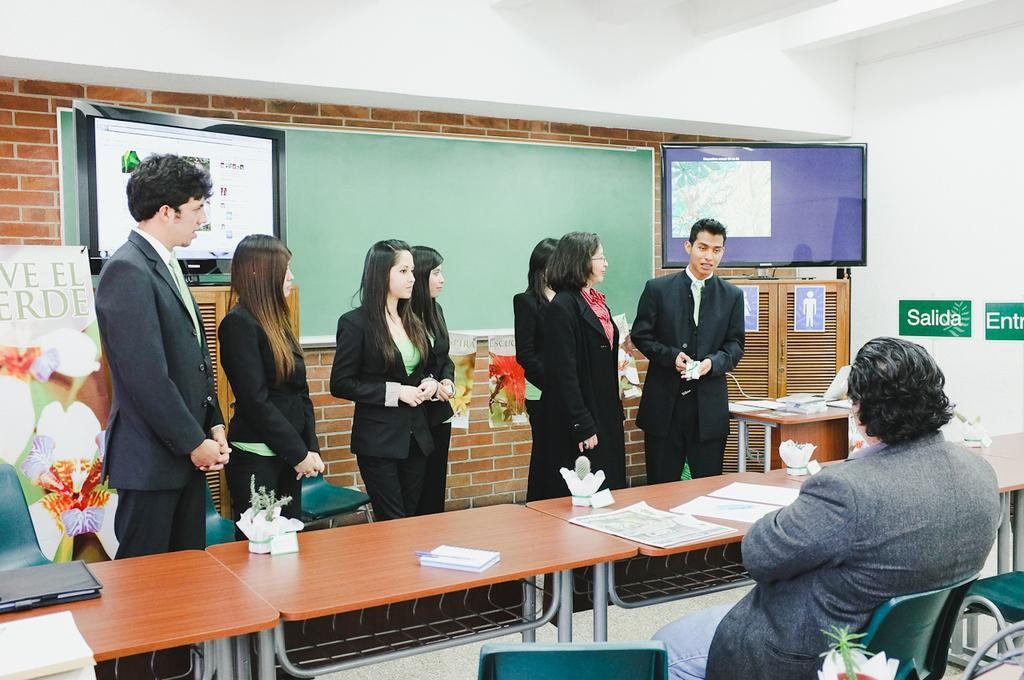Where was the image taken? The image was taken inside a room. Who or what can be seen in the room? There are people in the room. What furniture is present in the room? There is a table and chairs in the room. What objects are used for displaying information or presentations? There is a board and a monitor in the room. What type of wall decoration is present in the room? There is a poster with text in the room. What type of storage unit is present in the room? There is a cupboard in the room. What type of battle is depicted in the picture on the wall? There is no picture on the wall in the image, and therefore no battle can be observed. 